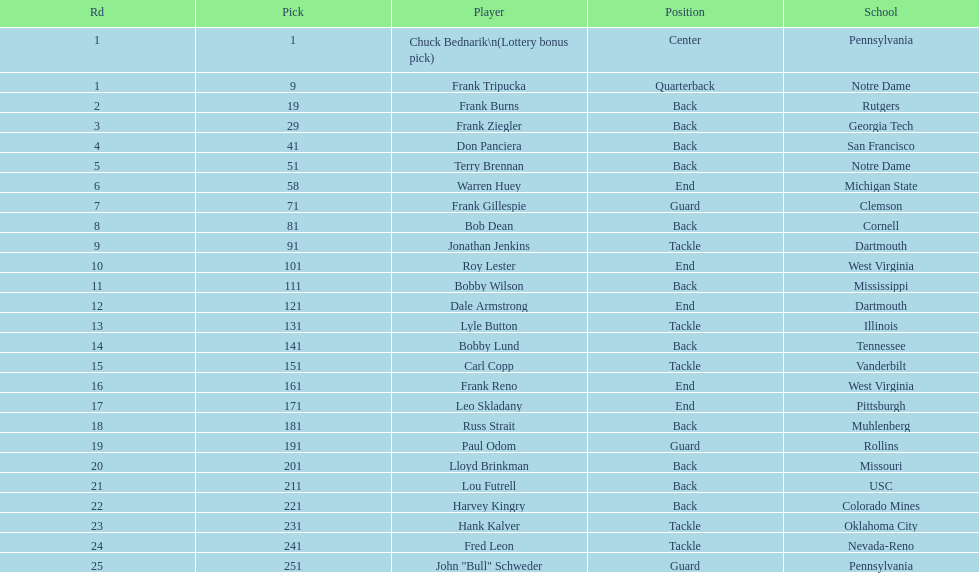Greatest rd figure? 25. 